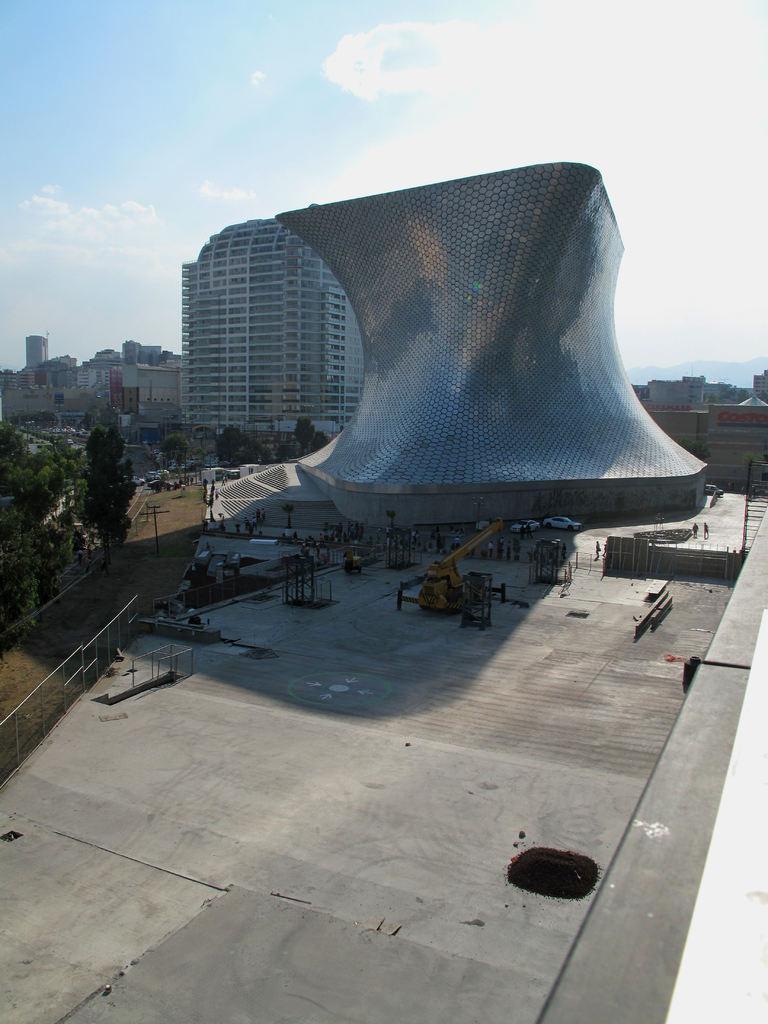Describe this image in one or two sentences. In this picture there is a building which is in different shape and there are few other objects beside it and there are few other buildings and trees in the background. 